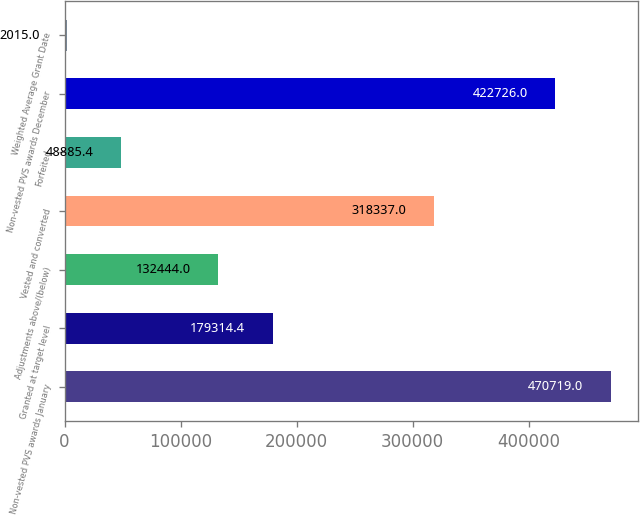Convert chart to OTSL. <chart><loc_0><loc_0><loc_500><loc_500><bar_chart><fcel>Non-vested PVS awards January<fcel>Granted at target level<fcel>Adjustments above/(below)<fcel>Vested and converted<fcel>Forfeited<fcel>Non-vested PVS awards December<fcel>Weighted Average Grant Date<nl><fcel>470719<fcel>179314<fcel>132444<fcel>318337<fcel>48885.4<fcel>422726<fcel>2015<nl></chart> 